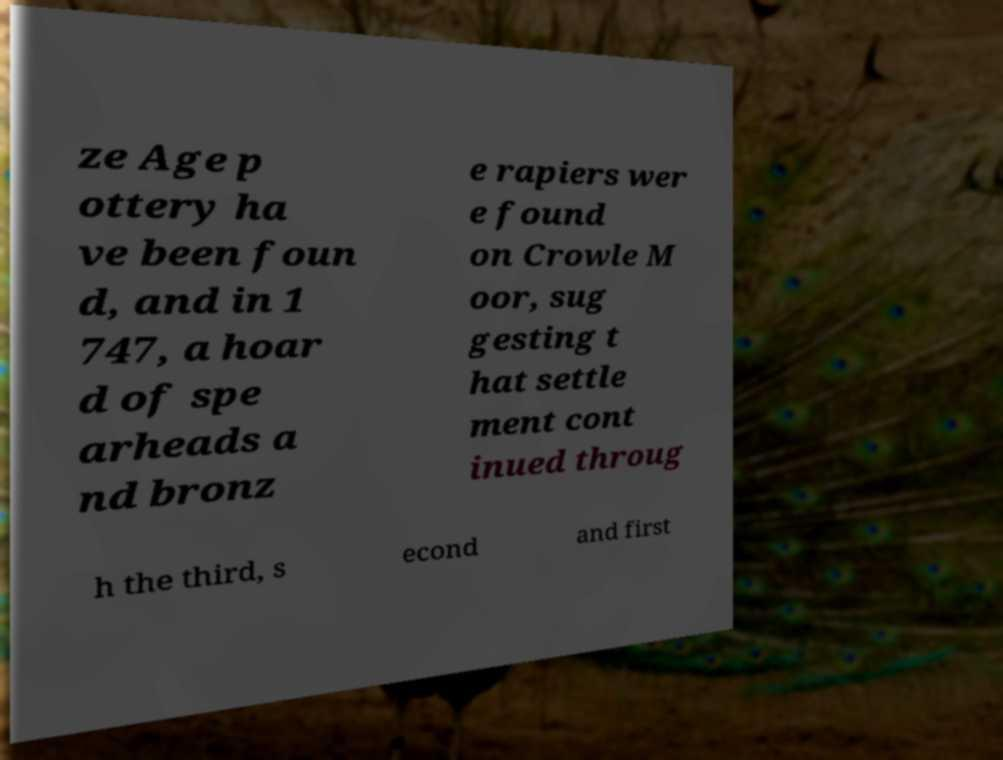What messages or text are displayed in this image? I need them in a readable, typed format. ze Age p ottery ha ve been foun d, and in 1 747, a hoar d of spe arheads a nd bronz e rapiers wer e found on Crowle M oor, sug gesting t hat settle ment cont inued throug h the third, s econd and first 